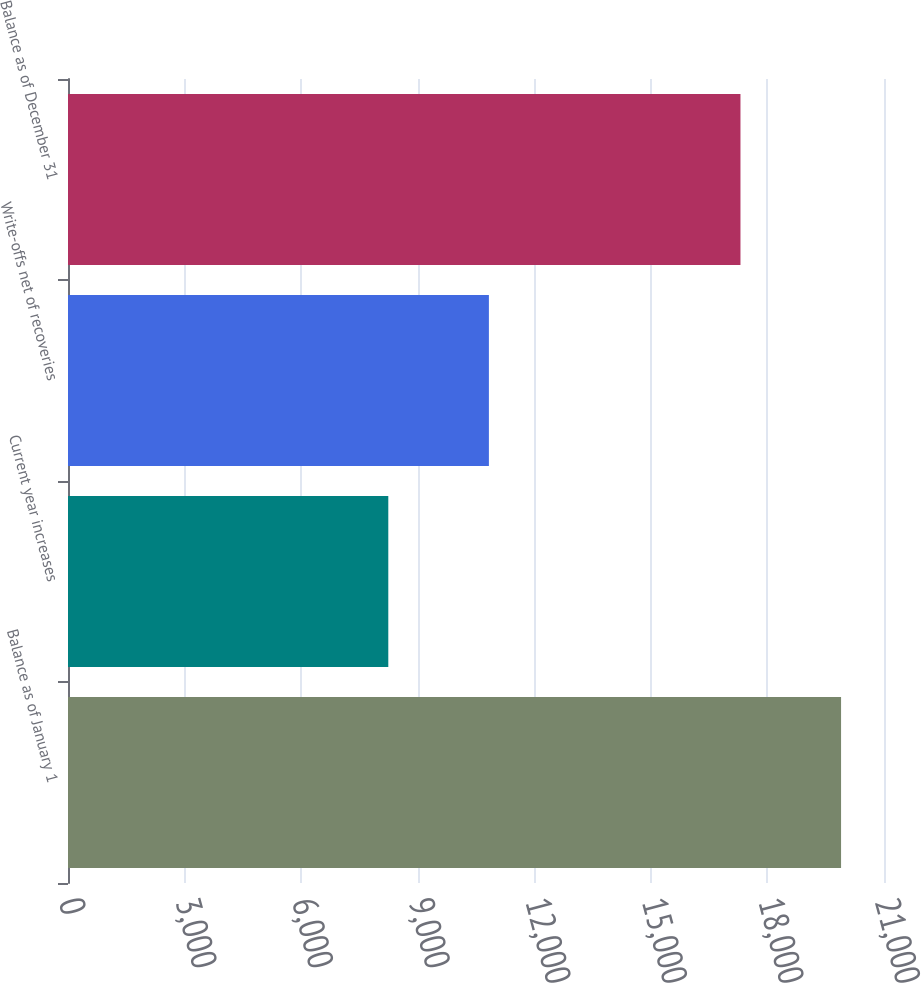<chart> <loc_0><loc_0><loc_500><loc_500><bar_chart><fcel>Balance as of January 1<fcel>Current year increases<fcel>Write-offs net of recoveries<fcel>Balance as of December 31<nl><fcel>19895<fcel>8243<fcel>10832<fcel>17306<nl></chart> 